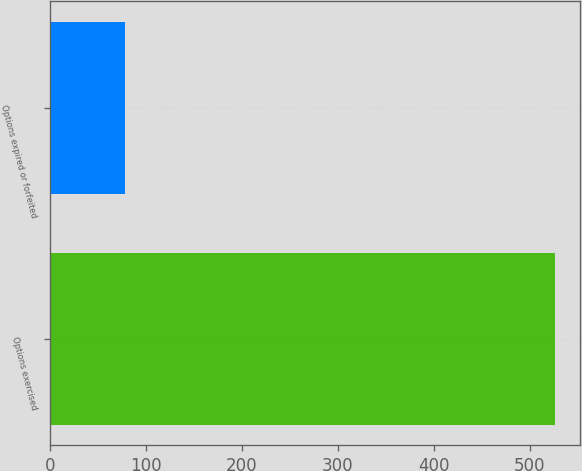Convert chart to OTSL. <chart><loc_0><loc_0><loc_500><loc_500><bar_chart><fcel>Options exercised<fcel>Options expired or forfeited<nl><fcel>526<fcel>78<nl></chart> 